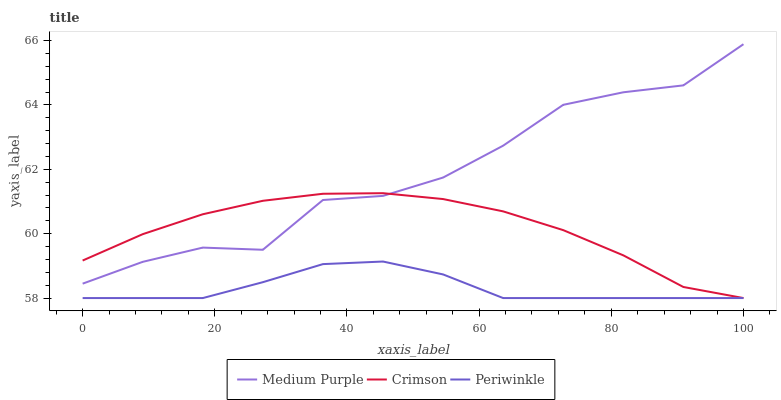Does Periwinkle have the minimum area under the curve?
Answer yes or no. Yes. Does Medium Purple have the maximum area under the curve?
Answer yes or no. Yes. Does Crimson have the minimum area under the curve?
Answer yes or no. No. Does Crimson have the maximum area under the curve?
Answer yes or no. No. Is Crimson the smoothest?
Answer yes or no. Yes. Is Medium Purple the roughest?
Answer yes or no. Yes. Is Periwinkle the smoothest?
Answer yes or no. No. Is Periwinkle the roughest?
Answer yes or no. No. Does Crimson have the lowest value?
Answer yes or no. Yes. Does Medium Purple have the highest value?
Answer yes or no. Yes. Does Crimson have the highest value?
Answer yes or no. No. Is Periwinkle less than Medium Purple?
Answer yes or no. Yes. Is Medium Purple greater than Periwinkle?
Answer yes or no. Yes. Does Periwinkle intersect Crimson?
Answer yes or no. Yes. Is Periwinkle less than Crimson?
Answer yes or no. No. Is Periwinkle greater than Crimson?
Answer yes or no. No. Does Periwinkle intersect Medium Purple?
Answer yes or no. No. 